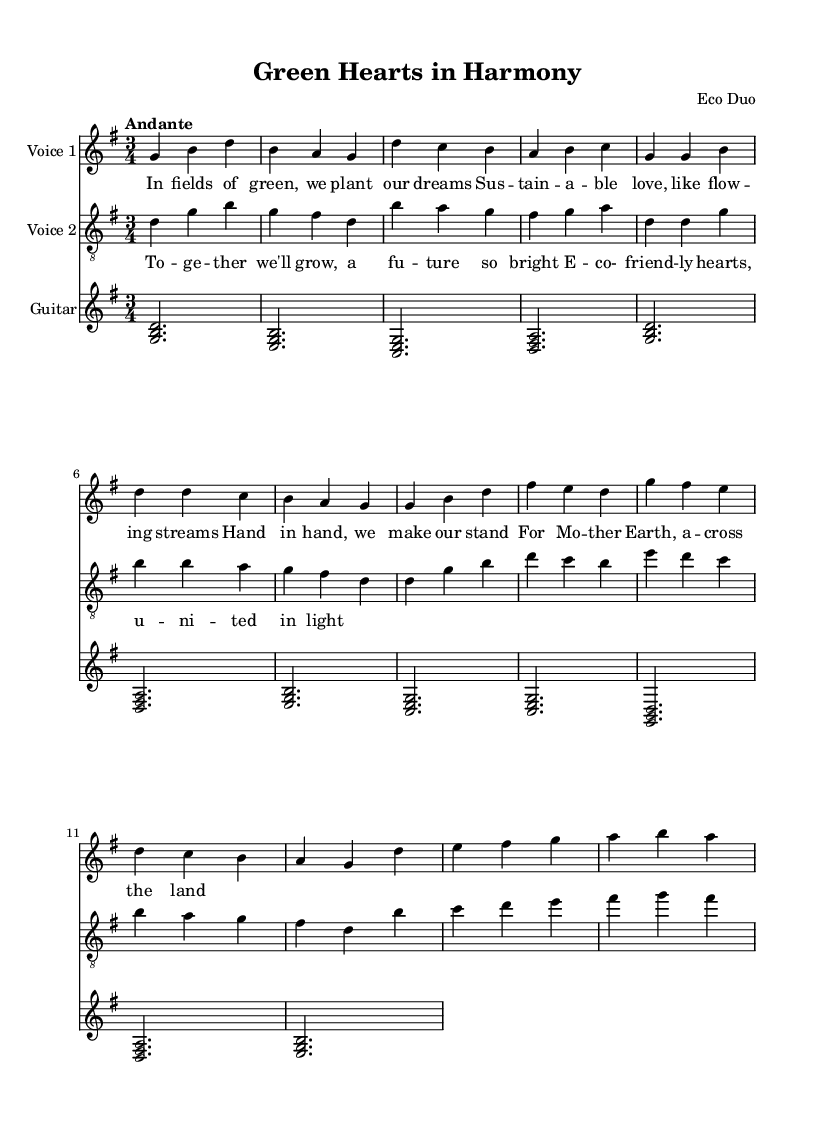What is the key signature of this music? The key signature is indicated at the beginning of the staff. It shows one sharp, which corresponds to G major.
Answer: G major What is the time signature of this music? The time signature is located at the beginning of the score, showing a 3 over 4, indicating there are three beats per measure.
Answer: 3/4 What is the tempo marking for the piece? The tempo marking appears as 'Andante' written above the staves, suggesting a moderately slow pace.
Answer: Andante How many voices are present in the piece? By examining the staves, there are two designated for voices (soprano and tenor) along with one for the guitar, making a total of three.
Answer: Two What imagery does the first verse suggest about the partnership celebrated in this song? The lyrics reference "fields of green" and "sustainable love," implying a deep connection to nature and shared eco-friendly values.
Answer: Environmental imagery What does the chorus emphasize about the partnership? The chorus highlights the unity and brightness of the future shared by the partners, stressing collaboration and hope for sustainability.
Answer: Unity and hope Which musical element contributes most to the romantic theme in this duet? The intertwining melodies of the soprano and tenor voices create a rich, harmonic texture that enhances the romantic feel of the piece.
Answer: Intertwining melodies 